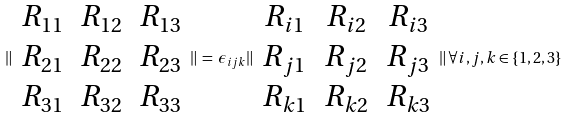Convert formula to latex. <formula><loc_0><loc_0><loc_500><loc_500>\| \begin{array} { c c c } R _ { 1 1 } & R _ { 1 2 } & R _ { 1 3 } \\ R _ { 2 1 } & R _ { 2 2 } & R _ { 2 3 } \\ R _ { 3 1 } & R _ { 3 2 } & R _ { 3 3 } \\ \end{array} \| \, = \, \epsilon _ { i j k } \| \begin{array} { c c c } R _ { i 1 } & R _ { i 2 } & R _ { i 3 } \\ R _ { j 1 } & R _ { j 2 } & R _ { j 3 } \\ R _ { k 1 } & R _ { k 2 } & R _ { k 3 } \\ \end{array} \| \, \forall i , j , k \in \{ 1 , 2 , 3 \}</formula> 